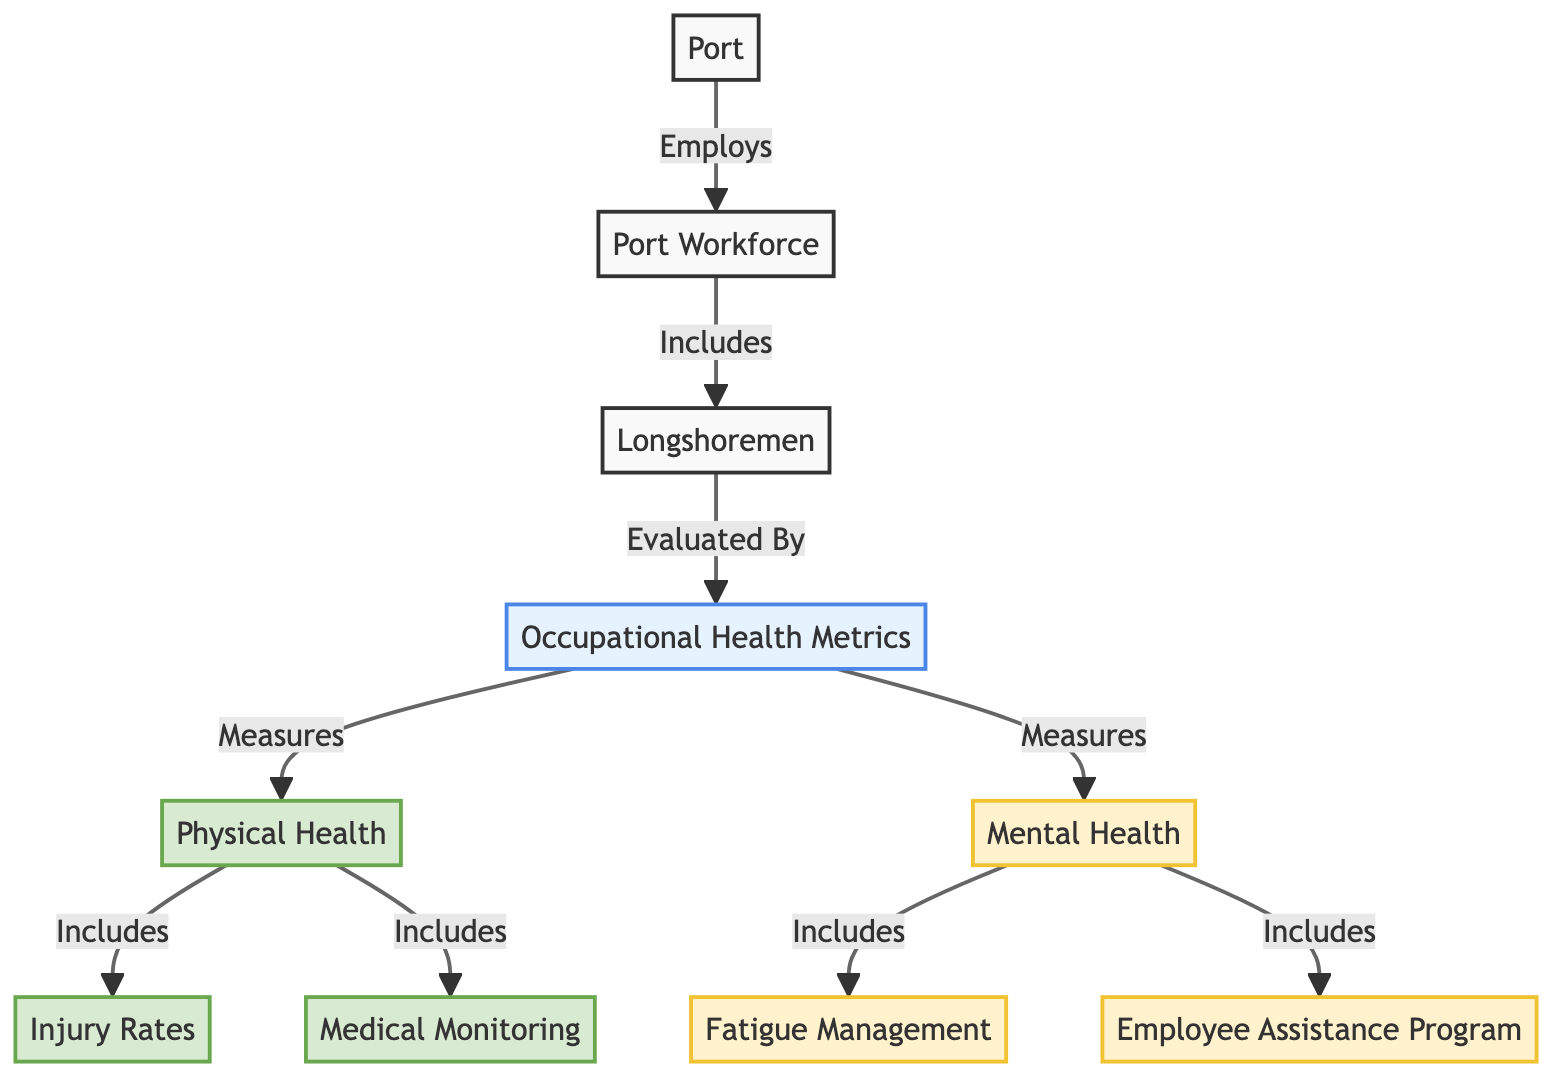What is the primary focus of the diagram? The diagram primarily focuses on "Port Workforce Health Readiness," which evaluates occupational health metrics for longshoremen. This can be inferred as the title conceptually guides the entire structure and elements represented in the diagram.
Answer: Port Workforce Health Readiness How many health metrics are included in the diagram? The diagram indicates two main categories under Health Metrics: Physical Health and Mental Health. Each of these categories contains subcomponents, but in total, there are two primary health metric categories.
Answer: 2 Which group is evaluated by health metrics? The "Longshoremen" group is specifically pointed out as the workforce evaluated by the Health Metrics. This relationship is directly established by the diagram's connectors.
Answer: Longshoremen What two types of health metrics are shown in the diagram? The diagram distinctly categorizes health metrics into "Physical Health" and "Mental Health," as depicted by the two main branches extending from HealthMetrics.
Answer: Physical Health, Mental Health Which element focuses on the management of worker fatigue? "Fatigue Management" is the element within the Mental Health section that specifically addresses the management of worker fatigue, as indicated by its placement connected to the Mental Health node.
Answer: Fatigue Management What aspect of physical health includes injury rates? "Injury Rates," directly illustrated as part of the Physical Health metrics, indicates that this metric is specifically related to the physical health dimension of longshoremen. Hence, it is a direct subcomponent of Physical Health.
Answer: Injury Rates What does the Employee Assistance Program (EAP) focus on? The "Employee Assistance Program (EAP)" is part of the Mental Health metrics, which indicates its focus on assisting longshoremen with mental health as it falls under that category of health readiness metrics.
Answer: Mental Health What connection does the "Port" have with the "Port Workforce"? The diagram shows that the "Port" employs the "Port Workforce," establishing a direct employment relationship visually represented with the arrow pointing from Port to Port Workforce.
Answer: Employs 